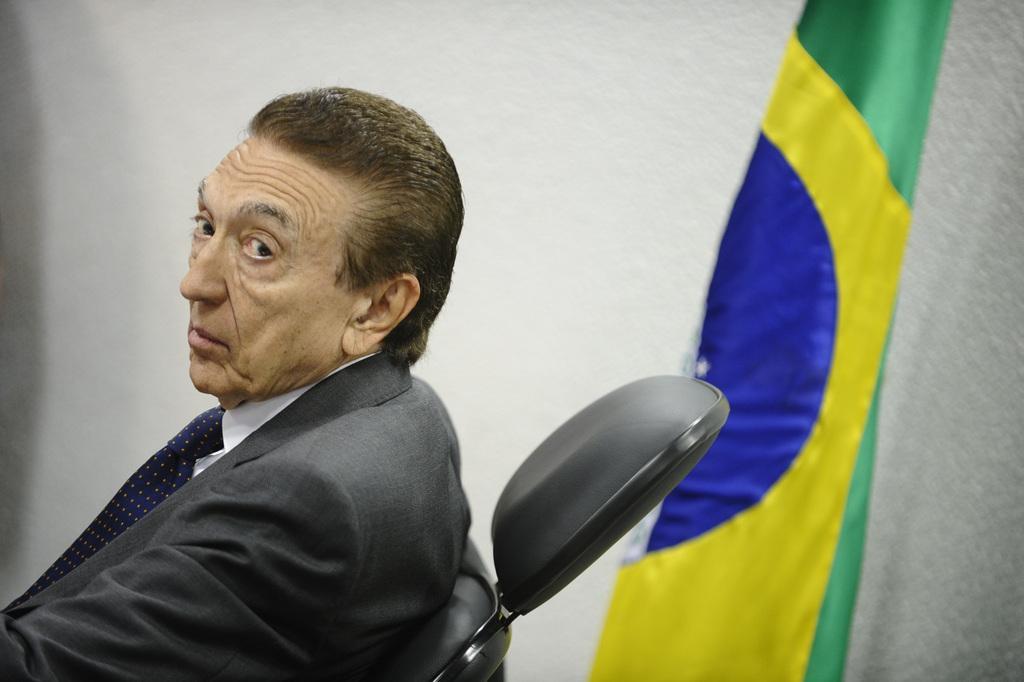Can you describe this image briefly? This picture seems to be clicked inside. On the right there is a flag and a wall. On the left there is a man wearing suit, blue color tie and sitting on the chair. 